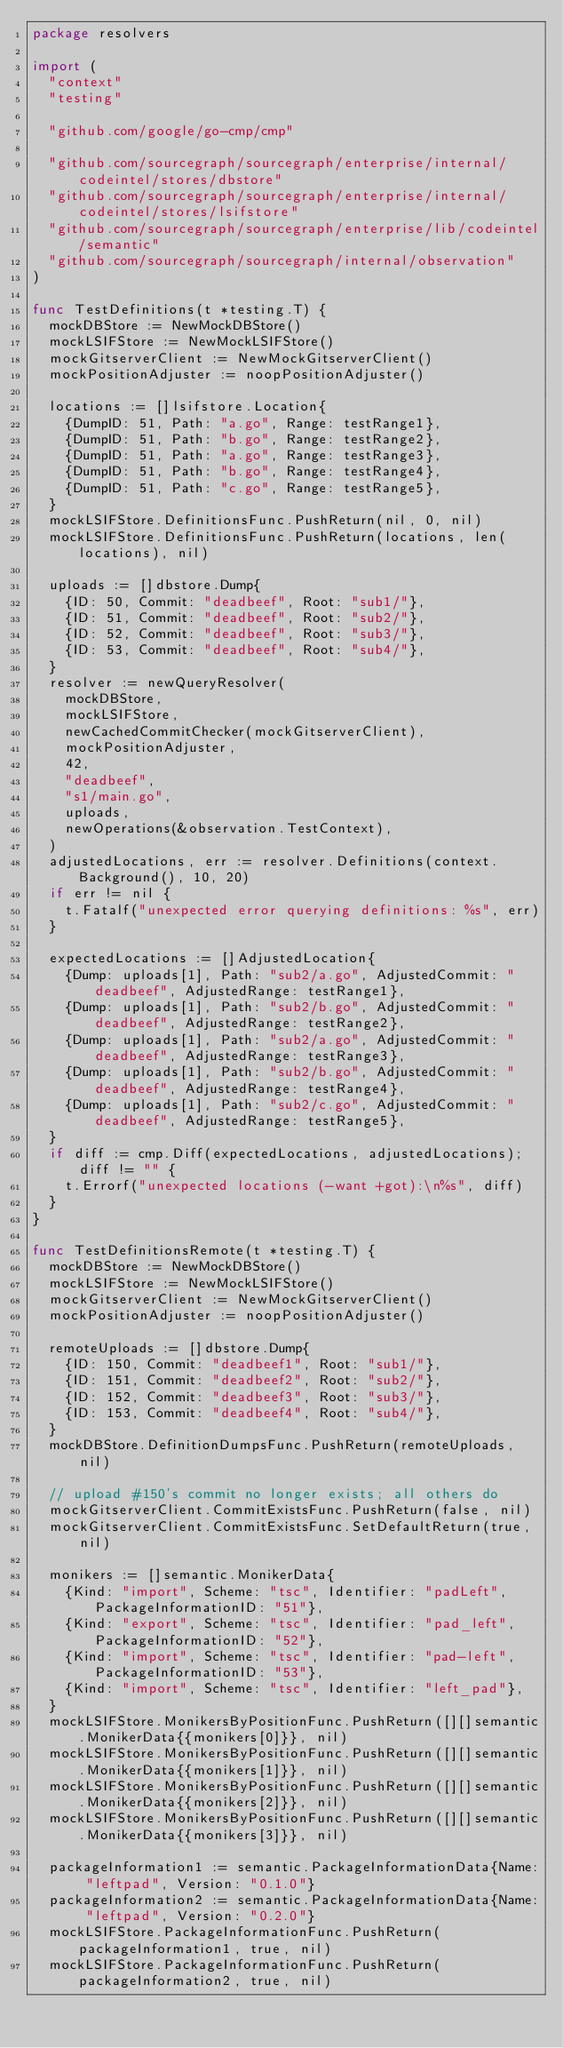Convert code to text. <code><loc_0><loc_0><loc_500><loc_500><_Go_>package resolvers

import (
	"context"
	"testing"

	"github.com/google/go-cmp/cmp"

	"github.com/sourcegraph/sourcegraph/enterprise/internal/codeintel/stores/dbstore"
	"github.com/sourcegraph/sourcegraph/enterprise/internal/codeintel/stores/lsifstore"
	"github.com/sourcegraph/sourcegraph/enterprise/lib/codeintel/semantic"
	"github.com/sourcegraph/sourcegraph/internal/observation"
)

func TestDefinitions(t *testing.T) {
	mockDBStore := NewMockDBStore()
	mockLSIFStore := NewMockLSIFStore()
	mockGitserverClient := NewMockGitserverClient()
	mockPositionAdjuster := noopPositionAdjuster()

	locations := []lsifstore.Location{
		{DumpID: 51, Path: "a.go", Range: testRange1},
		{DumpID: 51, Path: "b.go", Range: testRange2},
		{DumpID: 51, Path: "a.go", Range: testRange3},
		{DumpID: 51, Path: "b.go", Range: testRange4},
		{DumpID: 51, Path: "c.go", Range: testRange5},
	}
	mockLSIFStore.DefinitionsFunc.PushReturn(nil, 0, nil)
	mockLSIFStore.DefinitionsFunc.PushReturn(locations, len(locations), nil)

	uploads := []dbstore.Dump{
		{ID: 50, Commit: "deadbeef", Root: "sub1/"},
		{ID: 51, Commit: "deadbeef", Root: "sub2/"},
		{ID: 52, Commit: "deadbeef", Root: "sub3/"},
		{ID: 53, Commit: "deadbeef", Root: "sub4/"},
	}
	resolver := newQueryResolver(
		mockDBStore,
		mockLSIFStore,
		newCachedCommitChecker(mockGitserverClient),
		mockPositionAdjuster,
		42,
		"deadbeef",
		"s1/main.go",
		uploads,
		newOperations(&observation.TestContext),
	)
	adjustedLocations, err := resolver.Definitions(context.Background(), 10, 20)
	if err != nil {
		t.Fatalf("unexpected error querying definitions: %s", err)
	}

	expectedLocations := []AdjustedLocation{
		{Dump: uploads[1], Path: "sub2/a.go", AdjustedCommit: "deadbeef", AdjustedRange: testRange1},
		{Dump: uploads[1], Path: "sub2/b.go", AdjustedCommit: "deadbeef", AdjustedRange: testRange2},
		{Dump: uploads[1], Path: "sub2/a.go", AdjustedCommit: "deadbeef", AdjustedRange: testRange3},
		{Dump: uploads[1], Path: "sub2/b.go", AdjustedCommit: "deadbeef", AdjustedRange: testRange4},
		{Dump: uploads[1], Path: "sub2/c.go", AdjustedCommit: "deadbeef", AdjustedRange: testRange5},
	}
	if diff := cmp.Diff(expectedLocations, adjustedLocations); diff != "" {
		t.Errorf("unexpected locations (-want +got):\n%s", diff)
	}
}

func TestDefinitionsRemote(t *testing.T) {
	mockDBStore := NewMockDBStore()
	mockLSIFStore := NewMockLSIFStore()
	mockGitserverClient := NewMockGitserverClient()
	mockPositionAdjuster := noopPositionAdjuster()

	remoteUploads := []dbstore.Dump{
		{ID: 150, Commit: "deadbeef1", Root: "sub1/"},
		{ID: 151, Commit: "deadbeef2", Root: "sub2/"},
		{ID: 152, Commit: "deadbeef3", Root: "sub3/"},
		{ID: 153, Commit: "deadbeef4", Root: "sub4/"},
	}
	mockDBStore.DefinitionDumpsFunc.PushReturn(remoteUploads, nil)

	// upload #150's commit no longer exists; all others do
	mockGitserverClient.CommitExistsFunc.PushReturn(false, nil)
	mockGitserverClient.CommitExistsFunc.SetDefaultReturn(true, nil)

	monikers := []semantic.MonikerData{
		{Kind: "import", Scheme: "tsc", Identifier: "padLeft", PackageInformationID: "51"},
		{Kind: "export", Scheme: "tsc", Identifier: "pad_left", PackageInformationID: "52"},
		{Kind: "import", Scheme: "tsc", Identifier: "pad-left", PackageInformationID: "53"},
		{Kind: "import", Scheme: "tsc", Identifier: "left_pad"},
	}
	mockLSIFStore.MonikersByPositionFunc.PushReturn([][]semantic.MonikerData{{monikers[0]}}, nil)
	mockLSIFStore.MonikersByPositionFunc.PushReturn([][]semantic.MonikerData{{monikers[1]}}, nil)
	mockLSIFStore.MonikersByPositionFunc.PushReturn([][]semantic.MonikerData{{monikers[2]}}, nil)
	mockLSIFStore.MonikersByPositionFunc.PushReturn([][]semantic.MonikerData{{monikers[3]}}, nil)

	packageInformation1 := semantic.PackageInformationData{Name: "leftpad", Version: "0.1.0"}
	packageInformation2 := semantic.PackageInformationData{Name: "leftpad", Version: "0.2.0"}
	mockLSIFStore.PackageInformationFunc.PushReturn(packageInformation1, true, nil)
	mockLSIFStore.PackageInformationFunc.PushReturn(packageInformation2, true, nil)
</code> 